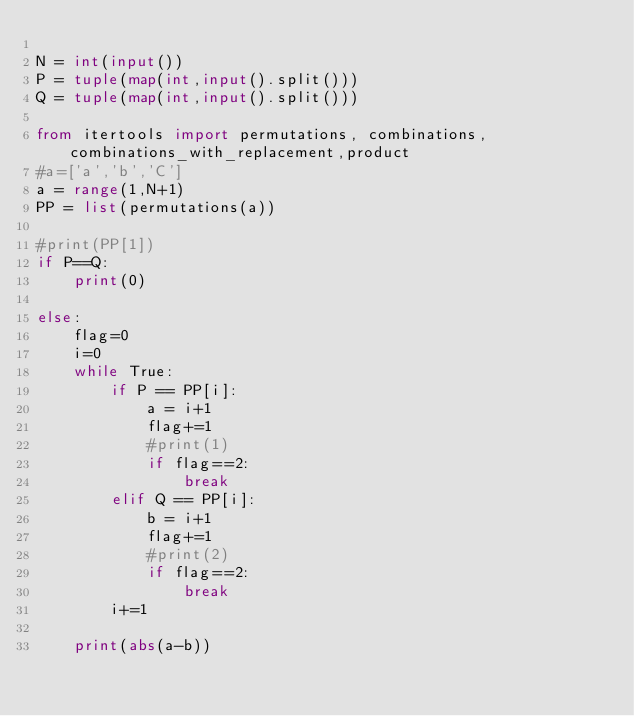Convert code to text. <code><loc_0><loc_0><loc_500><loc_500><_Python_>
N = int(input())
P = tuple(map(int,input().split()))
Q = tuple(map(int,input().split()))

from itertools import permutations, combinations,combinations_with_replacement,product
#a=['a','b','C']
a = range(1,N+1)
PP = list(permutations(a))

#print(PP[1])
if P==Q:
    print(0)

else:
    flag=0
    i=0
    while True:
        if P == PP[i]:
            a = i+1
            flag+=1
            #print(1)
            if flag==2:
                break
        elif Q == PP[i]:
            b = i+1
            flag+=1
            #print(2)
            if flag==2:
                break
        i+=1

    print(abs(a-b))</code> 